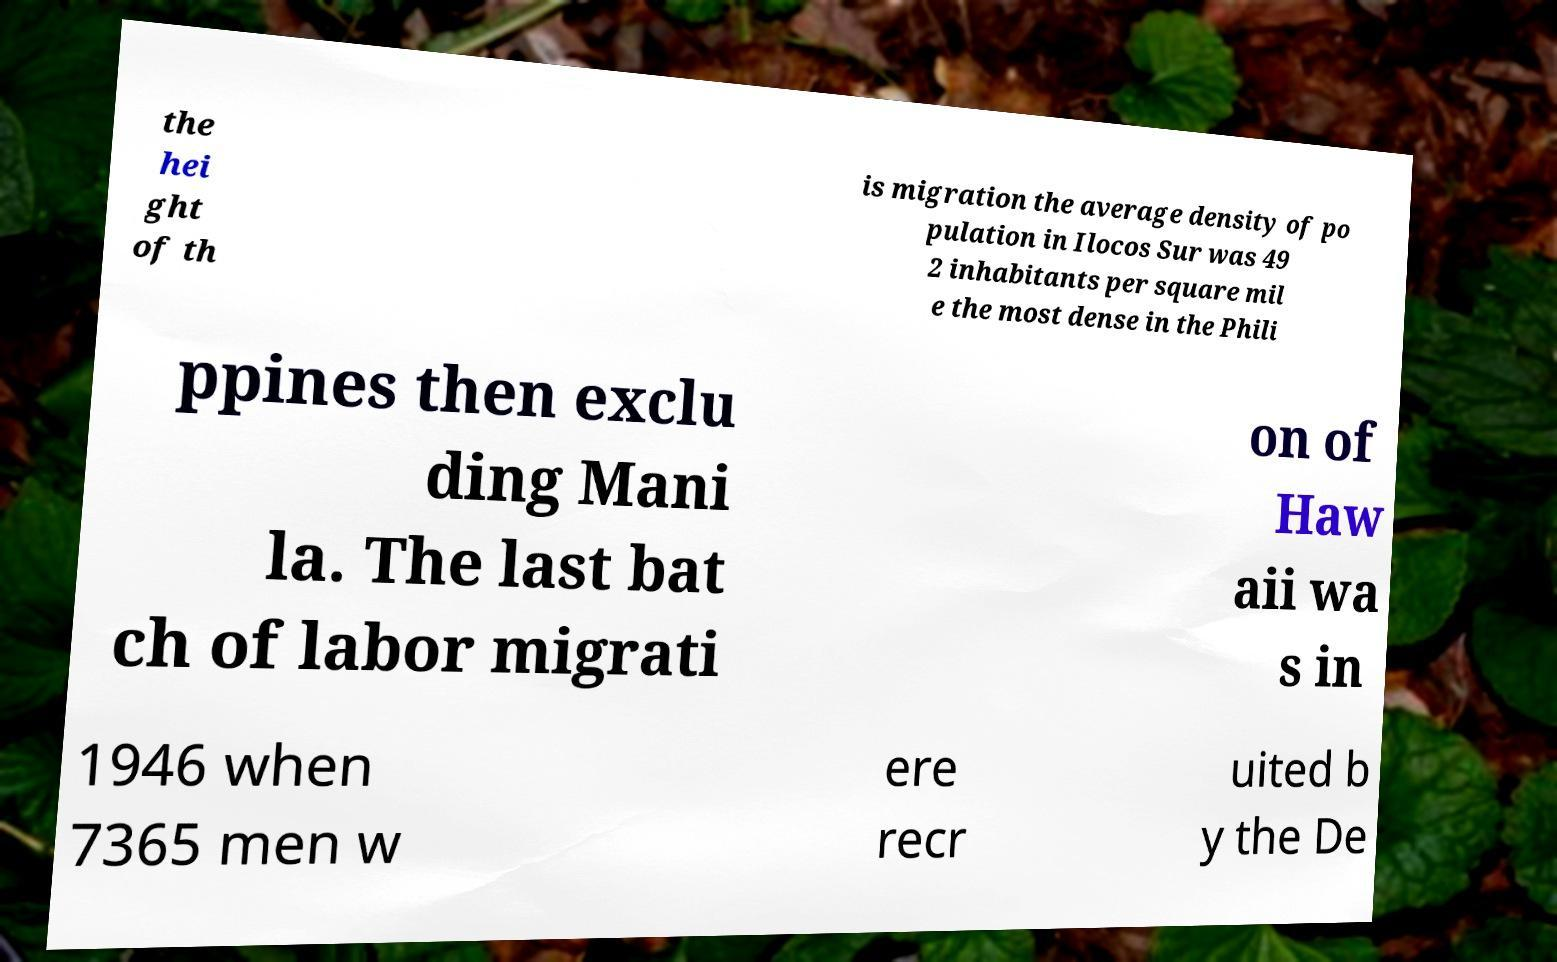Please identify and transcribe the text found in this image. the hei ght of th is migration the average density of po pulation in Ilocos Sur was 49 2 inhabitants per square mil e the most dense in the Phili ppines then exclu ding Mani la. The last bat ch of labor migrati on of Haw aii wa s in 1946 when 7365 men w ere recr uited b y the De 